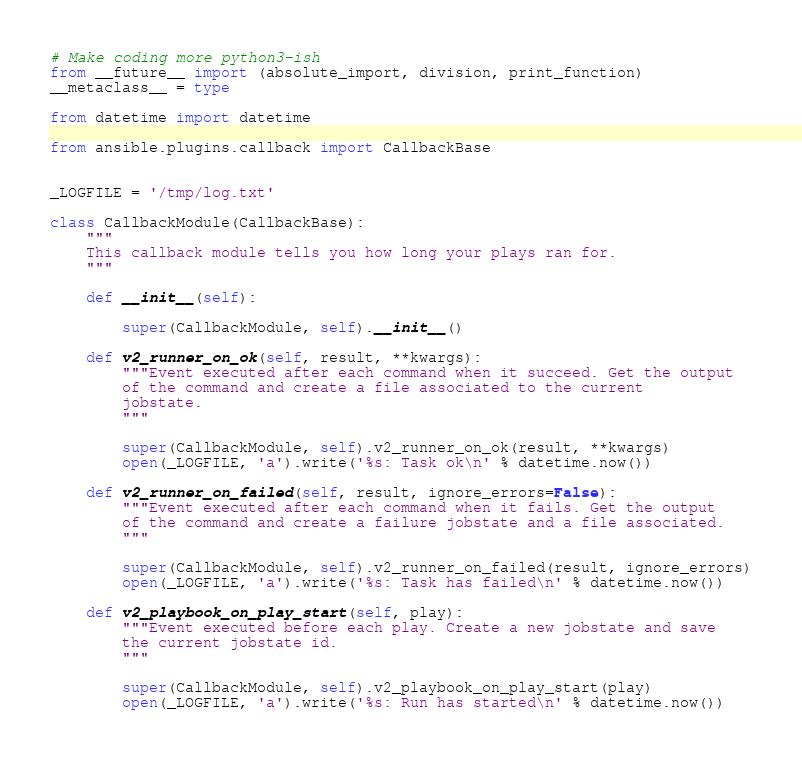<code> <loc_0><loc_0><loc_500><loc_500><_Python_># Make coding more python3-ish
from __future__ import (absolute_import, division, print_function)
__metaclass__ = type

from datetime import datetime

from ansible.plugins.callback import CallbackBase


_LOGFILE = '/tmp/log.txt'

class CallbackModule(CallbackBase):
    """
    This callback module tells you how long your plays ran for.
    """

    def __init__(self):

        super(CallbackModule, self).__init__()

    def v2_runner_on_ok(self, result, **kwargs):
        """Event executed after each command when it succeed. Get the output
        of the command and create a file associated to the current
        jobstate.
        """

        super(CallbackModule, self).v2_runner_on_ok(result, **kwargs)
        open(_LOGFILE, 'a').write('%s: Task ok\n' % datetime.now())

    def v2_runner_on_failed(self, result, ignore_errors=False):
        """Event executed after each command when it fails. Get the output
        of the command and create a failure jobstate and a file associated.
        """

        super(CallbackModule, self).v2_runner_on_failed(result, ignore_errors)
        open(_LOGFILE, 'a').write('%s: Task has failed\n' % datetime.now())

    def v2_playbook_on_play_start(self, play):
        """Event executed before each play. Create a new jobstate and save
        the current jobstate id.
        """

        super(CallbackModule, self).v2_playbook_on_play_start(play)
        open(_LOGFILE, 'a').write('%s: Run has started\n' % datetime.now())
</code> 